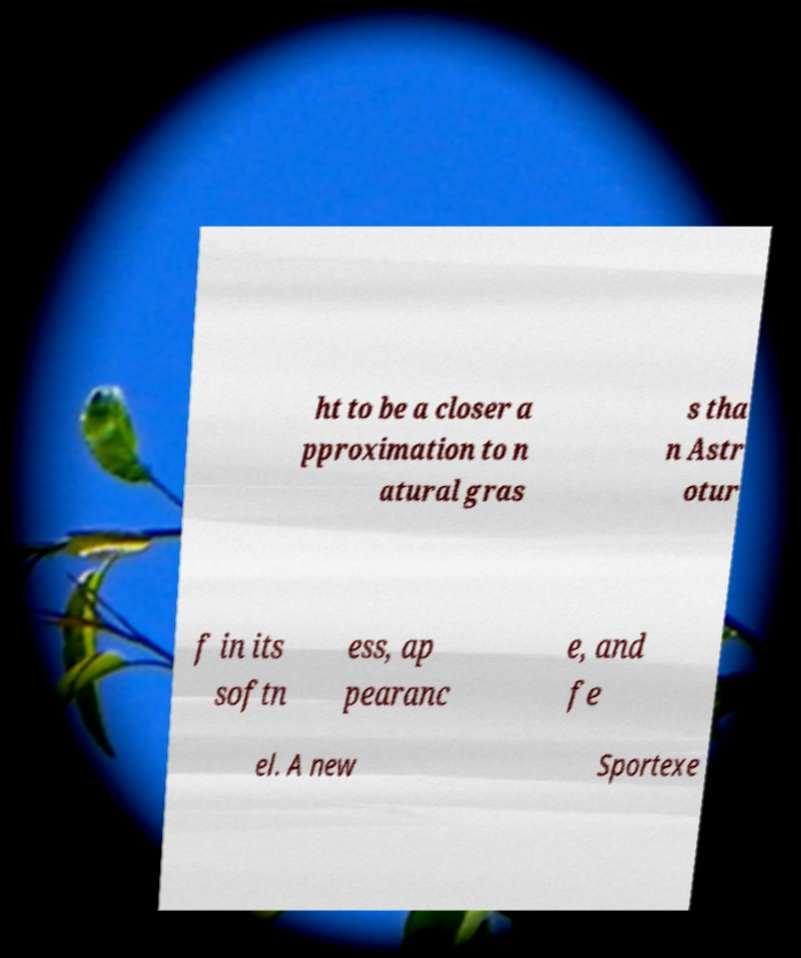What messages or text are displayed in this image? I need them in a readable, typed format. ht to be a closer a pproximation to n atural gras s tha n Astr otur f in its softn ess, ap pearanc e, and fe el. A new Sportexe 